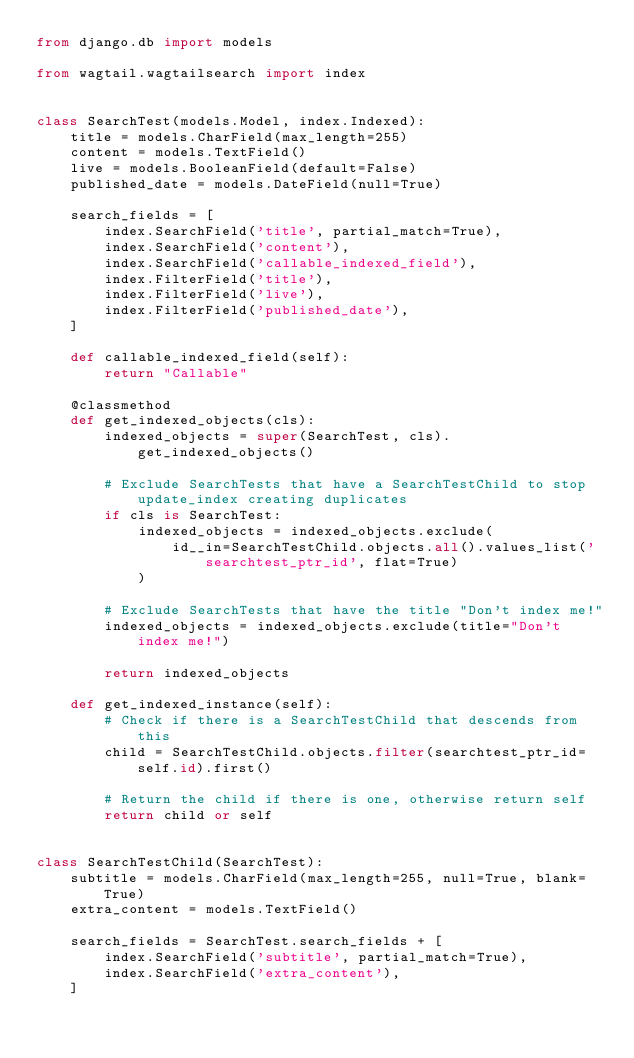<code> <loc_0><loc_0><loc_500><loc_500><_Python_>from django.db import models

from wagtail.wagtailsearch import index


class SearchTest(models.Model, index.Indexed):
    title = models.CharField(max_length=255)
    content = models.TextField()
    live = models.BooleanField(default=False)
    published_date = models.DateField(null=True)

    search_fields = [
        index.SearchField('title', partial_match=True),
        index.SearchField('content'),
        index.SearchField('callable_indexed_field'),
        index.FilterField('title'),
        index.FilterField('live'),
        index.FilterField('published_date'),
    ]

    def callable_indexed_field(self):
        return "Callable"

    @classmethod
    def get_indexed_objects(cls):
        indexed_objects = super(SearchTest, cls).get_indexed_objects()

        # Exclude SearchTests that have a SearchTestChild to stop update_index creating duplicates
        if cls is SearchTest:
            indexed_objects = indexed_objects.exclude(
                id__in=SearchTestChild.objects.all().values_list('searchtest_ptr_id', flat=True)
            )

        # Exclude SearchTests that have the title "Don't index me!"
        indexed_objects = indexed_objects.exclude(title="Don't index me!")

        return indexed_objects

    def get_indexed_instance(self):
        # Check if there is a SearchTestChild that descends from this
        child = SearchTestChild.objects.filter(searchtest_ptr_id=self.id).first()

        # Return the child if there is one, otherwise return self
        return child or self


class SearchTestChild(SearchTest):
    subtitle = models.CharField(max_length=255, null=True, blank=True)
    extra_content = models.TextField()

    search_fields = SearchTest.search_fields + [
        index.SearchField('subtitle', partial_match=True),
        index.SearchField('extra_content'),
    ]
</code> 